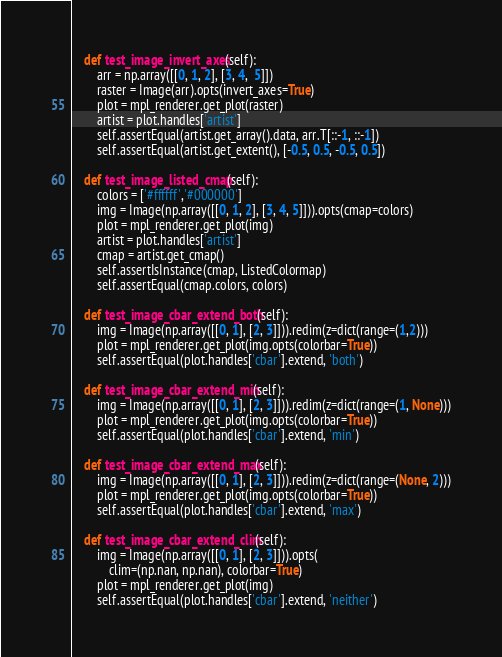Convert code to text. <code><loc_0><loc_0><loc_500><loc_500><_Python_>
    def test_image_invert_axes(self):
        arr = np.array([[0, 1, 2], [3, 4,  5]])
        raster = Image(arr).opts(invert_axes=True)
        plot = mpl_renderer.get_plot(raster)
        artist = plot.handles['artist']
        self.assertEqual(artist.get_array().data, arr.T[::-1, ::-1])
        self.assertEqual(artist.get_extent(), [-0.5, 0.5, -0.5, 0.5])

    def test_image_listed_cmap(self):
        colors = ['#ffffff','#000000']
        img = Image(np.array([[0, 1, 2], [3, 4, 5]])).opts(cmap=colors)
        plot = mpl_renderer.get_plot(img)
        artist = plot.handles['artist']
        cmap = artist.get_cmap()
        self.assertIsInstance(cmap, ListedColormap)
        self.assertEqual(cmap.colors, colors)

    def test_image_cbar_extend_both(self):
        img = Image(np.array([[0, 1], [2, 3]])).redim(z=dict(range=(1,2)))
        plot = mpl_renderer.get_plot(img.opts(colorbar=True))
        self.assertEqual(plot.handles['cbar'].extend, 'both')

    def test_image_cbar_extend_min(self):
        img = Image(np.array([[0, 1], [2, 3]])).redim(z=dict(range=(1, None)))
        plot = mpl_renderer.get_plot(img.opts(colorbar=True))
        self.assertEqual(plot.handles['cbar'].extend, 'min')

    def test_image_cbar_extend_max(self):
        img = Image(np.array([[0, 1], [2, 3]])).redim(z=dict(range=(None, 2)))
        plot = mpl_renderer.get_plot(img.opts(colorbar=True))
        self.assertEqual(plot.handles['cbar'].extend, 'max')

    def test_image_cbar_extend_clim(self):
        img = Image(np.array([[0, 1], [2, 3]])).opts(
            clim=(np.nan, np.nan), colorbar=True)
        plot = mpl_renderer.get_plot(img)
        self.assertEqual(plot.handles['cbar'].extend, 'neither')
</code> 